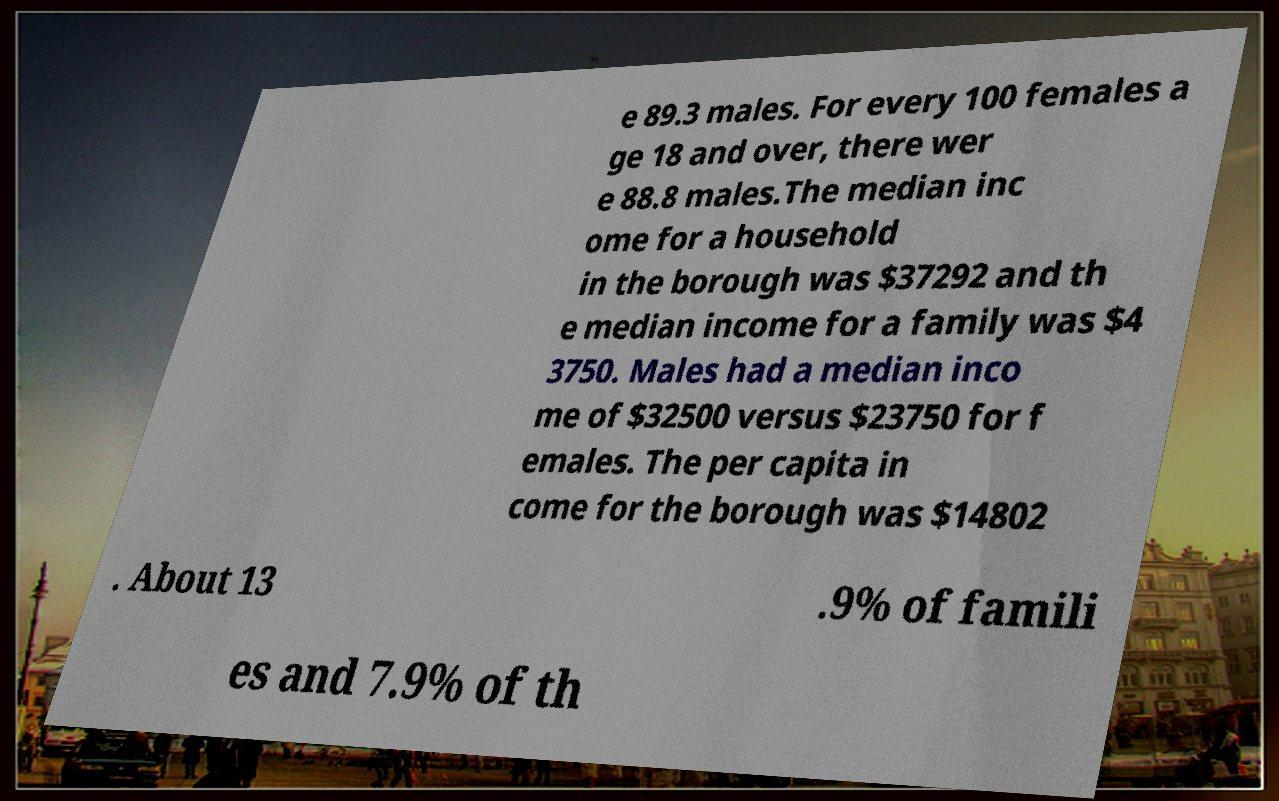Please read and relay the text visible in this image. What does it say? e 89.3 males. For every 100 females a ge 18 and over, there wer e 88.8 males.The median inc ome for a household in the borough was $37292 and th e median income for a family was $4 3750. Males had a median inco me of $32500 versus $23750 for f emales. The per capita in come for the borough was $14802 . About 13 .9% of famili es and 7.9% of th 